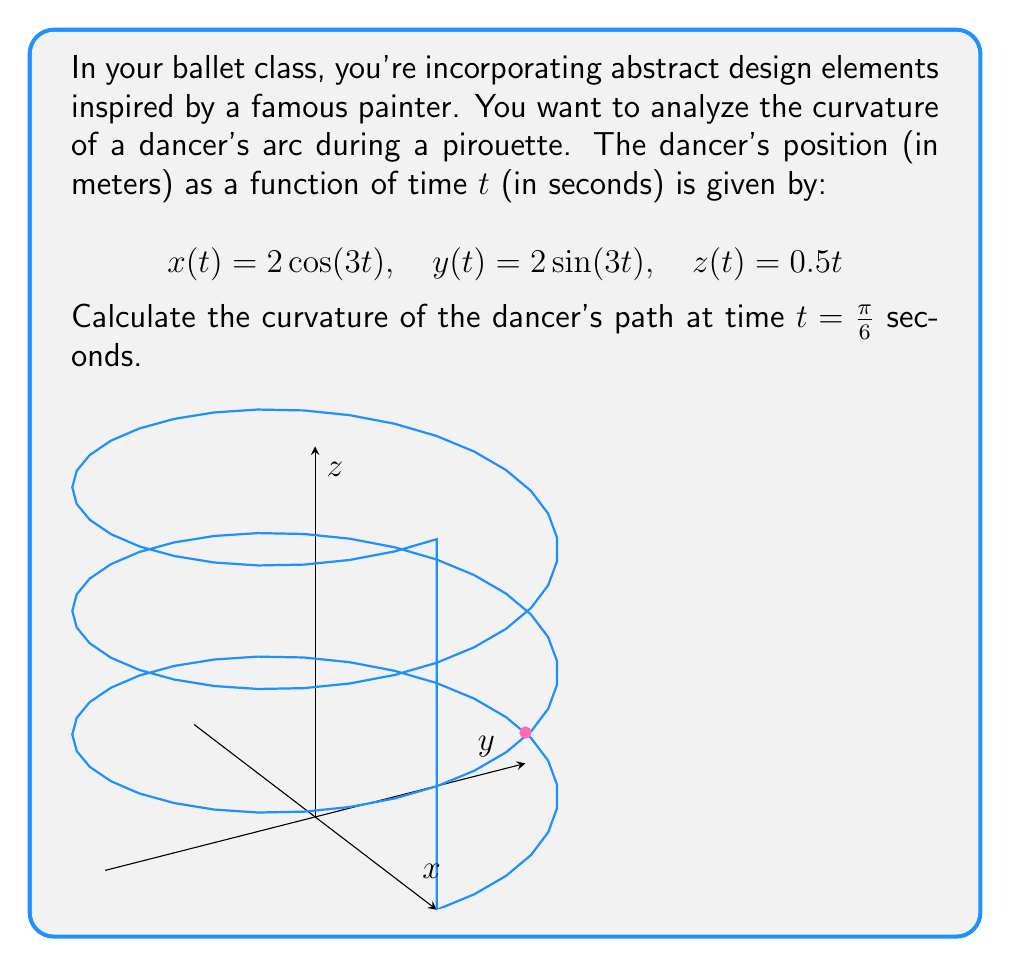Teach me how to tackle this problem. Let's approach this step-by-step:

1) The curvature κ for a 3D parametric curve is given by:

   $$κ = \frac{|\mathbf{r}'(t) × \mathbf{r}''(t)|}{|\mathbf{r}'(t)|^3}$$

   where $\mathbf{r}(t) = (x(t), y(t), z(t))$

2) First, we need to find $\mathbf{r}'(t)$ and $\mathbf{r}''(t)$:

   $$\mathbf{r}'(t) = (-6\sin(3t), 6\cos(3t), 0.5)$$
   $$\mathbf{r}''(t) = (-18\cos(3t), -18\sin(3t), 0)$$

3) Now, let's calculate $\mathbf{r}'(t) × \mathbf{r}''(t)$:

   $$\mathbf{r}'(t) × \mathbf{r}''(t) = \begin{vmatrix} 
   \mathbf{i} & \mathbf{j} & \mathbf{k} \\
   -6\sin(3t) & 6\cos(3t) & 0.5 \\
   -18\cos(3t) & -18\sin(3t) & 0
   \end{vmatrix}$$

   $$= (9\sin(3t), 9\cos(3t), 108\sin^2(3t) + 108\cos^2(3t))$$
   $$= (9\sin(3t), 9\cos(3t), 108)$$

4) The magnitude of this cross product is:

   $$|\mathbf{r}'(t) × \mathbf{r}''(t)| = \sqrt{81\sin^2(3t) + 81\cos^2(3t) + 11664} = \sqrt{11745}$$

5) Now, let's calculate $|\mathbf{r}'(t)|^3$:

   $$|\mathbf{r}'(t)|^3 = (36\sin^2(3t) + 36\cos^2(3t) + 0.25)^{3/2} = (36 + 0.25)^{3/2} = 216.375$$

6) Therefore, the curvature at any time t is:

   $$κ = \frac{\sqrt{11745}}{216.375} ≈ 0.5$$

7) This curvature is constant for all t, including t = π/6.
Answer: $0.5$ 